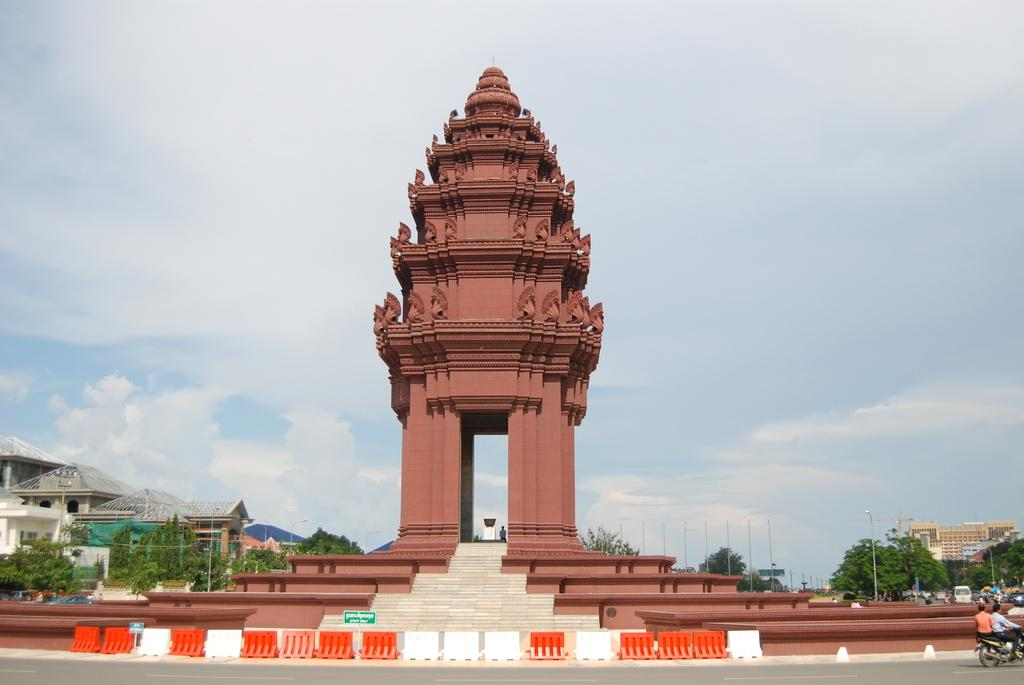What type of structures can be seen in the image? There are buildings in the image. What natural elements are present in the image? There are trees in the image. What man-made object is featured in the image? There is a monument in the image. What mode of transportation is visible in the image? There is a motorcycle in the image. What is happening on the road in the image? There are vehicles moving on the road in the image. What type of lighting is present in the image? There are pole lights in the image. How would you describe the weather in the image? The sky is cloudy in the image. Can you see any icicles hanging from the buildings in the image? There are no icicles present in the image; the sky is cloudy, but not cold enough for icicles to form. Is there a tiger roaming around the monument in the image? There is no tiger present in the image; only the motorcycle, vehicles, and other man-made objects are visible. 